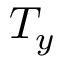Convert formula to latex. <formula><loc_0><loc_0><loc_500><loc_500>T _ { y }</formula> 